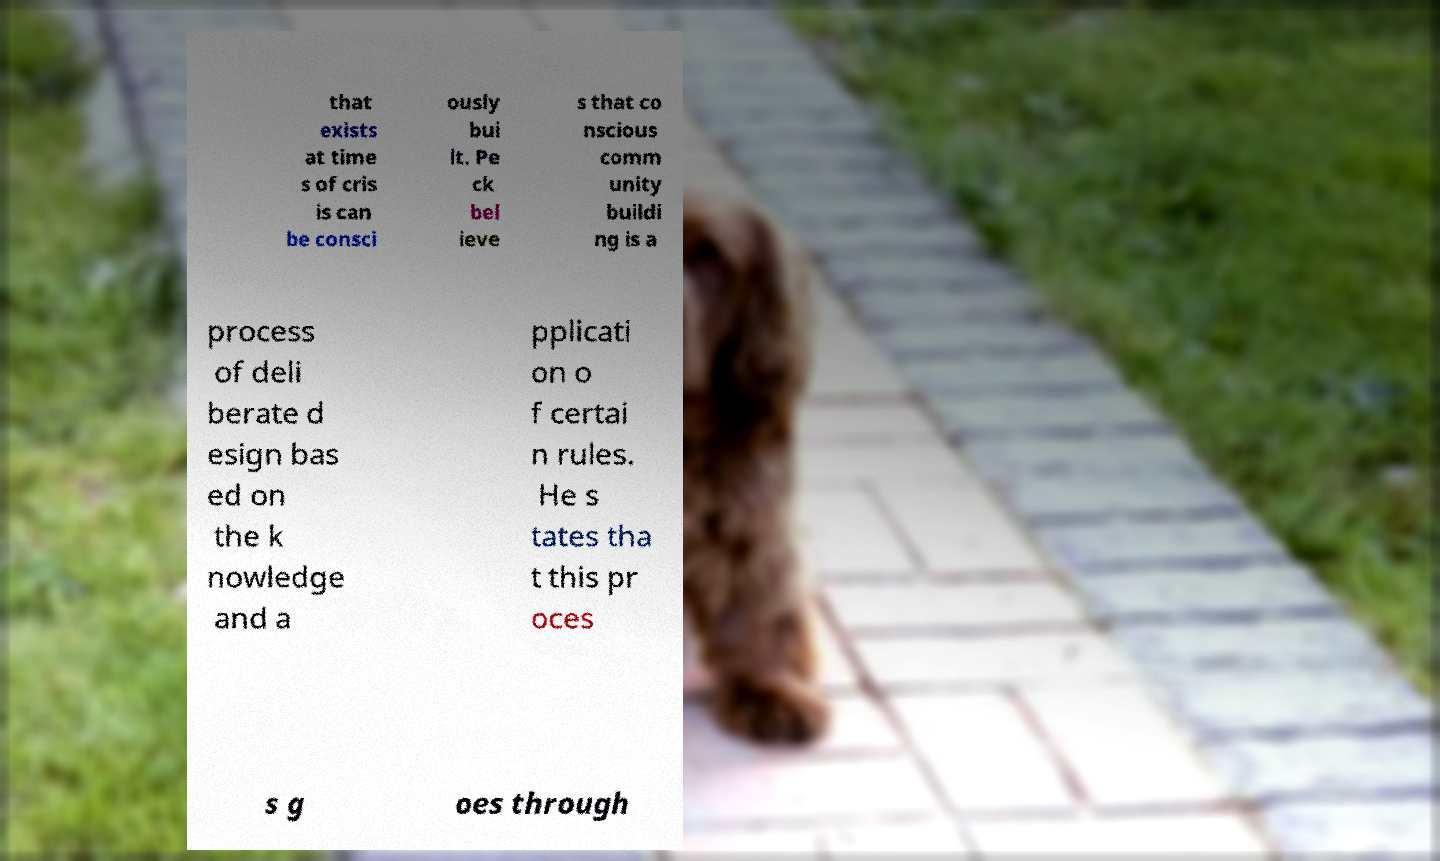Could you assist in decoding the text presented in this image and type it out clearly? that exists at time s of cris is can be consci ously bui lt. Pe ck bel ieve s that co nscious comm unity buildi ng is a process of deli berate d esign bas ed on the k nowledge and a pplicati on o f certai n rules. He s tates tha t this pr oces s g oes through 